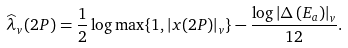<formula> <loc_0><loc_0><loc_500><loc_500>\widehat { \lambda } _ { v } ( 2 P ) = \frac { 1 } { 2 } \log \max \{ 1 , \left | x ( 2 P ) \right | _ { v } \} - \frac { \log \left | \Delta \left ( E _ { a } \right ) \right | _ { v } } { 1 2 } .</formula> 